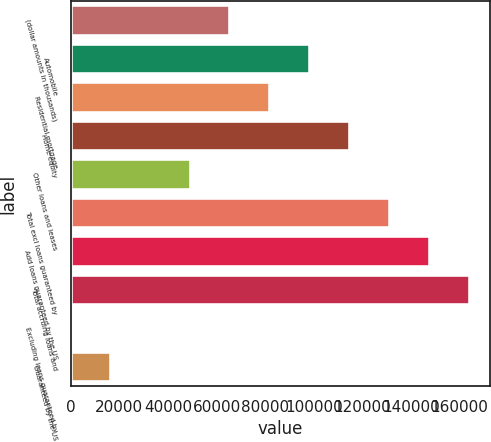Convert chart to OTSL. <chart><loc_0><loc_0><loc_500><loc_500><bar_chart><fcel>(dollar amounts in thousands)<fcel>Automobile<fcel>Residential mortgage<fcel>Home equity<fcel>Other loans and leases<fcel>Total excl loans guaranteed by<fcel>Add loans guaranteed by the US<fcel>Total accruing loans and<fcel>Excluding loans guaranteed by<fcel>Guaranteed by the US<nl><fcel>65677.7<fcel>98516.5<fcel>82097.1<fcel>114936<fcel>49258.3<fcel>131355<fcel>147775<fcel>164194<fcel>0.18<fcel>16419.6<nl></chart> 